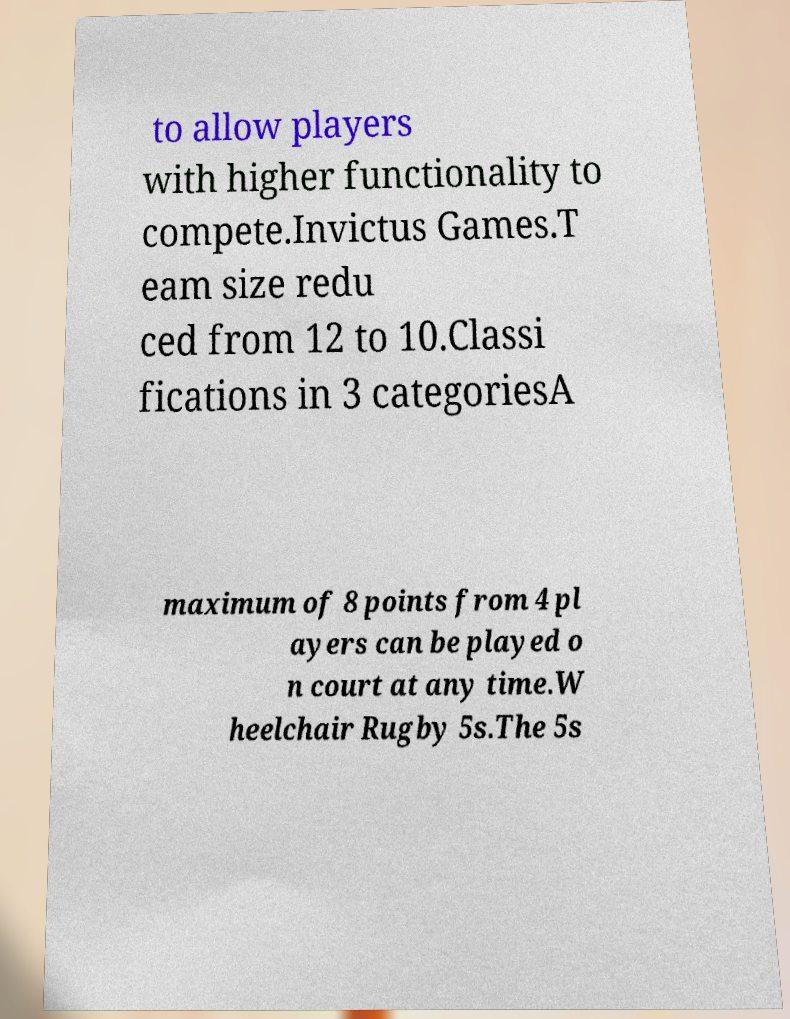Could you assist in decoding the text presented in this image and type it out clearly? to allow players with higher functionality to compete.Invictus Games.T eam size redu ced from 12 to 10.Classi fications in 3 categoriesA maximum of 8 points from 4 pl ayers can be played o n court at any time.W heelchair Rugby 5s.The 5s 